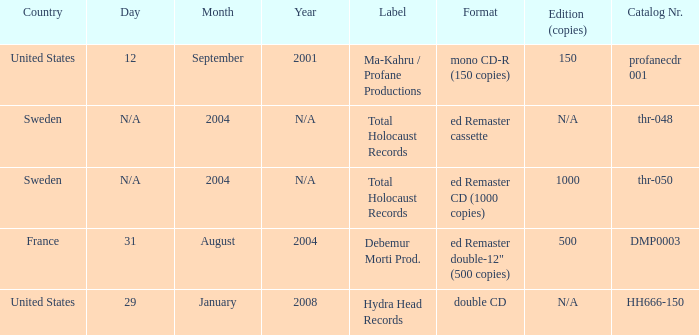Which date has Total Holocaust records in the ed Remaster cassette format? 2004.0. 